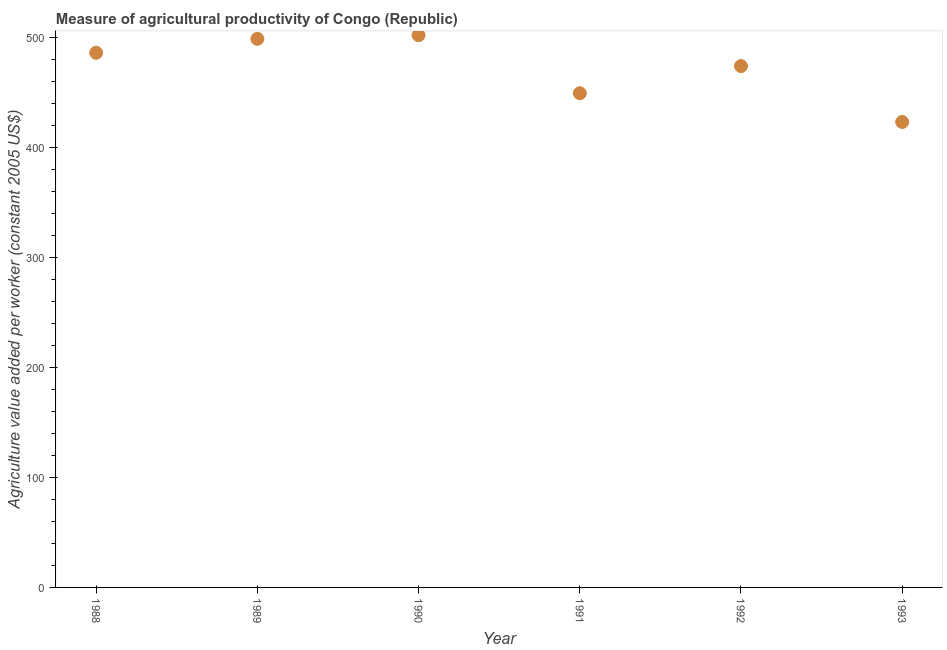What is the agriculture value added per worker in 1993?
Make the answer very short. 423.48. Across all years, what is the maximum agriculture value added per worker?
Offer a very short reply. 502.42. Across all years, what is the minimum agriculture value added per worker?
Keep it short and to the point. 423.48. In which year was the agriculture value added per worker minimum?
Offer a terse response. 1993. What is the sum of the agriculture value added per worker?
Your answer should be compact. 2835.27. What is the difference between the agriculture value added per worker in 1991 and 1992?
Your answer should be compact. -24.69. What is the average agriculture value added per worker per year?
Ensure brevity in your answer.  472.55. What is the median agriculture value added per worker?
Offer a terse response. 480.35. Do a majority of the years between 1991 and 1989 (inclusive) have agriculture value added per worker greater than 180 US$?
Your response must be concise. No. What is the ratio of the agriculture value added per worker in 1989 to that in 1992?
Keep it short and to the point. 1.05. Is the agriculture value added per worker in 1989 less than that in 1993?
Your response must be concise. No. What is the difference between the highest and the second highest agriculture value added per worker?
Offer a very short reply. 3.35. What is the difference between the highest and the lowest agriculture value added per worker?
Offer a terse response. 78.95. In how many years, is the agriculture value added per worker greater than the average agriculture value added per worker taken over all years?
Give a very brief answer. 4. Does the agriculture value added per worker monotonically increase over the years?
Provide a succinct answer. No. How many dotlines are there?
Your answer should be compact. 1. Are the values on the major ticks of Y-axis written in scientific E-notation?
Provide a succinct answer. No. Does the graph contain grids?
Give a very brief answer. No. What is the title of the graph?
Offer a terse response. Measure of agricultural productivity of Congo (Republic). What is the label or title of the X-axis?
Your response must be concise. Year. What is the label or title of the Y-axis?
Provide a succinct answer. Agriculture value added per worker (constant 2005 US$). What is the Agriculture value added per worker (constant 2005 US$) in 1988?
Make the answer very short. 486.39. What is the Agriculture value added per worker (constant 2005 US$) in 1989?
Provide a succinct answer. 499.07. What is the Agriculture value added per worker (constant 2005 US$) in 1990?
Make the answer very short. 502.42. What is the Agriculture value added per worker (constant 2005 US$) in 1991?
Provide a short and direct response. 449.61. What is the Agriculture value added per worker (constant 2005 US$) in 1992?
Make the answer very short. 474.3. What is the Agriculture value added per worker (constant 2005 US$) in 1993?
Offer a very short reply. 423.48. What is the difference between the Agriculture value added per worker (constant 2005 US$) in 1988 and 1989?
Provide a succinct answer. -12.68. What is the difference between the Agriculture value added per worker (constant 2005 US$) in 1988 and 1990?
Provide a short and direct response. -16.03. What is the difference between the Agriculture value added per worker (constant 2005 US$) in 1988 and 1991?
Ensure brevity in your answer.  36.78. What is the difference between the Agriculture value added per worker (constant 2005 US$) in 1988 and 1992?
Your answer should be very brief. 12.09. What is the difference between the Agriculture value added per worker (constant 2005 US$) in 1988 and 1993?
Keep it short and to the point. 62.92. What is the difference between the Agriculture value added per worker (constant 2005 US$) in 1989 and 1990?
Your answer should be very brief. -3.35. What is the difference between the Agriculture value added per worker (constant 2005 US$) in 1989 and 1991?
Offer a very short reply. 49.46. What is the difference between the Agriculture value added per worker (constant 2005 US$) in 1989 and 1992?
Provide a short and direct response. 24.77. What is the difference between the Agriculture value added per worker (constant 2005 US$) in 1989 and 1993?
Ensure brevity in your answer.  75.59. What is the difference between the Agriculture value added per worker (constant 2005 US$) in 1990 and 1991?
Provide a succinct answer. 52.81. What is the difference between the Agriculture value added per worker (constant 2005 US$) in 1990 and 1992?
Provide a short and direct response. 28.12. What is the difference between the Agriculture value added per worker (constant 2005 US$) in 1990 and 1993?
Offer a terse response. 78.95. What is the difference between the Agriculture value added per worker (constant 2005 US$) in 1991 and 1992?
Give a very brief answer. -24.69. What is the difference between the Agriculture value added per worker (constant 2005 US$) in 1991 and 1993?
Your answer should be compact. 26.13. What is the difference between the Agriculture value added per worker (constant 2005 US$) in 1992 and 1993?
Ensure brevity in your answer.  50.83. What is the ratio of the Agriculture value added per worker (constant 2005 US$) in 1988 to that in 1990?
Keep it short and to the point. 0.97. What is the ratio of the Agriculture value added per worker (constant 2005 US$) in 1988 to that in 1991?
Offer a terse response. 1.08. What is the ratio of the Agriculture value added per worker (constant 2005 US$) in 1988 to that in 1993?
Give a very brief answer. 1.15. What is the ratio of the Agriculture value added per worker (constant 2005 US$) in 1989 to that in 1991?
Give a very brief answer. 1.11. What is the ratio of the Agriculture value added per worker (constant 2005 US$) in 1989 to that in 1992?
Provide a succinct answer. 1.05. What is the ratio of the Agriculture value added per worker (constant 2005 US$) in 1989 to that in 1993?
Provide a short and direct response. 1.18. What is the ratio of the Agriculture value added per worker (constant 2005 US$) in 1990 to that in 1991?
Ensure brevity in your answer.  1.12. What is the ratio of the Agriculture value added per worker (constant 2005 US$) in 1990 to that in 1992?
Provide a succinct answer. 1.06. What is the ratio of the Agriculture value added per worker (constant 2005 US$) in 1990 to that in 1993?
Offer a very short reply. 1.19. What is the ratio of the Agriculture value added per worker (constant 2005 US$) in 1991 to that in 1992?
Keep it short and to the point. 0.95. What is the ratio of the Agriculture value added per worker (constant 2005 US$) in 1991 to that in 1993?
Your response must be concise. 1.06. What is the ratio of the Agriculture value added per worker (constant 2005 US$) in 1992 to that in 1993?
Your answer should be compact. 1.12. 